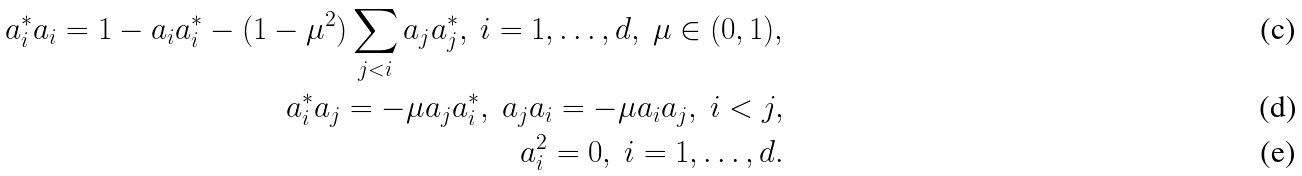Convert formula to latex. <formula><loc_0><loc_0><loc_500><loc_500>a _ { i } ^ { * } a _ { i } = 1 - a _ { i } a _ { i } ^ { * } - ( 1 - \mu ^ { 2 } ) \sum _ { j < i } a _ { j } a _ { j } ^ { * } , \ i = 1 , \dots , d , \ \mu \in ( 0 , 1 ) , \\ a _ { i } ^ { * } a _ { j } = - \mu a _ { j } a _ { i } ^ { * } , \ a _ { j } a _ { i } = - \mu a _ { i } a _ { j } , \ i < j , \\ a _ { i } ^ { 2 } = 0 , \ i = 1 , \dots , d .</formula> 